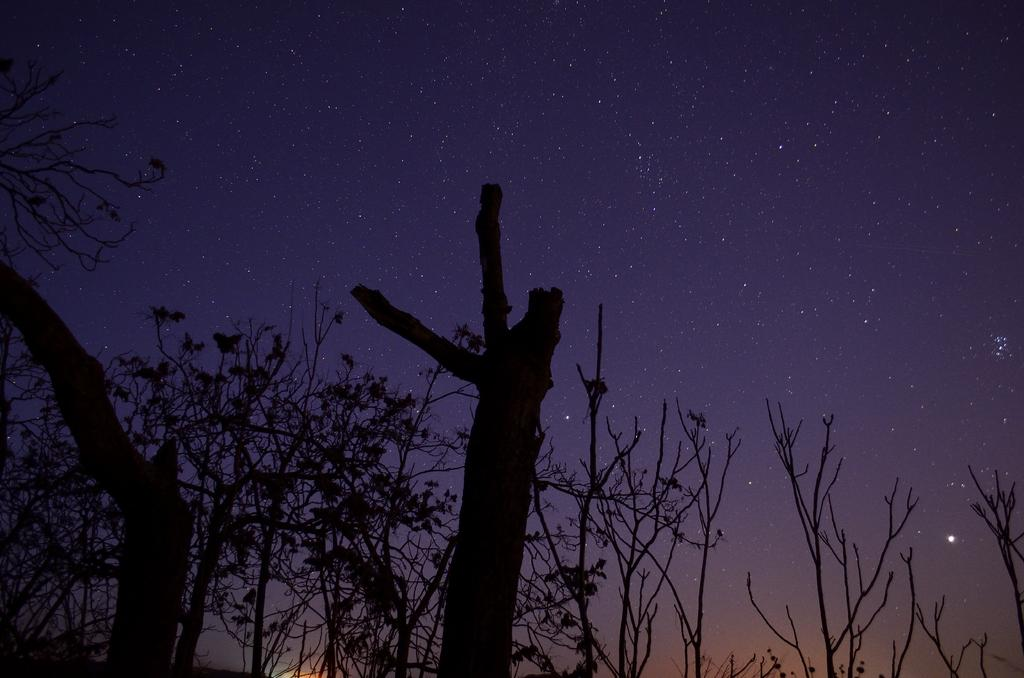What type of natural elements can be seen at the bottom of the image? There are trees and branches at the bottom of the image. What can be seen in the background of the image? The sky is visible in the background of the image. What celestial objects are present in the sky? Stars are present in the sky. What type of good-bye apparatus is being used by the stars in the image? There is no good-bye apparatus present in the image, and the stars are not using any such device. How many beads are visible on the branches in the image? There are no beads present on the branches in the image. 